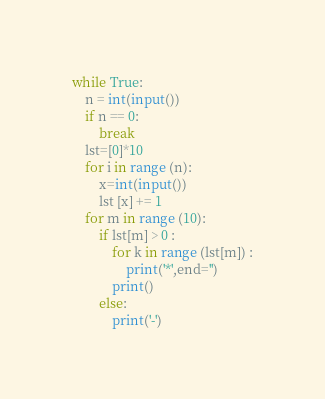<code> <loc_0><loc_0><loc_500><loc_500><_Python_>while True:
    n = int(input())
    if n == 0:
        break
    lst=[0]*10
    for i in range (n):
        x=int(input())
        lst [x] += 1
    for m in range (10):
        if lst[m] > 0 :
            for k in range (lst[m]) :
                print('*',end='')
            print()
        else:
            print('-')

</code> 